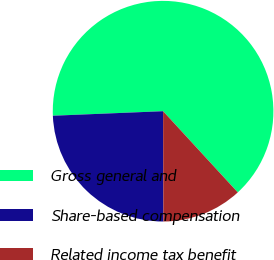Convert chart. <chart><loc_0><loc_0><loc_500><loc_500><pie_chart><fcel>Gross general and<fcel>Share-based compensation<fcel>Related income tax benefit<nl><fcel>63.82%<fcel>24.39%<fcel>11.79%<nl></chart> 